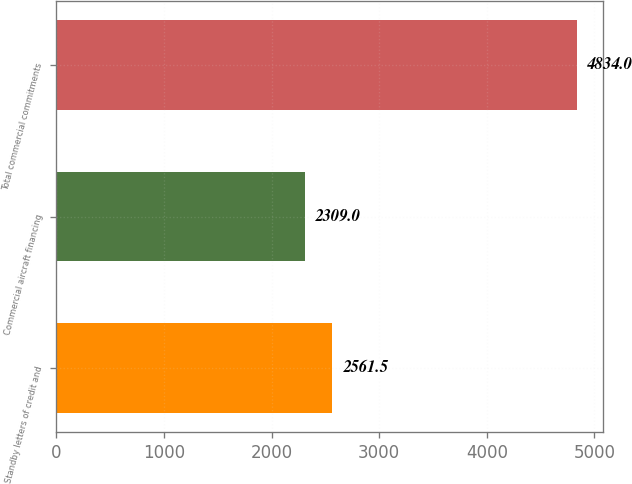<chart> <loc_0><loc_0><loc_500><loc_500><bar_chart><fcel>Standby letters of credit and<fcel>Commercial aircraft financing<fcel>Total commercial commitments<nl><fcel>2561.5<fcel>2309<fcel>4834<nl></chart> 